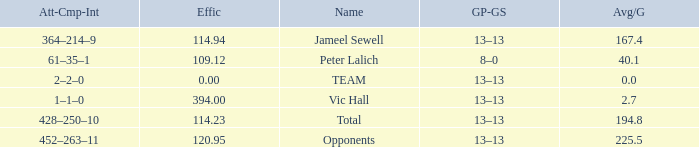Avg/G smaller than 225.5, and a GP-GS of 8–0 has what name? Peter Lalich. 